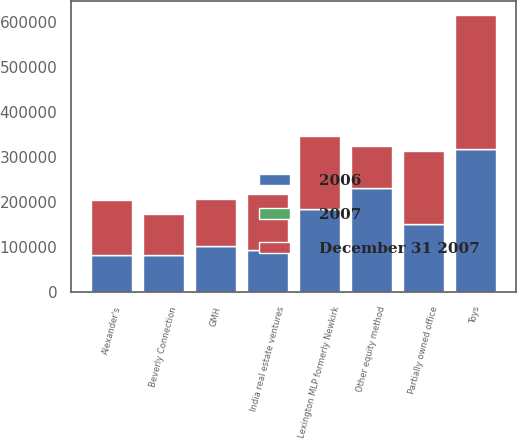Convert chart. <chart><loc_0><loc_0><loc_500><loc_500><stacked_bar_chart><ecel><fcel>Toys<fcel>Partially owned office<fcel>Lexington MLP formerly Newkirk<fcel>India real estate ventures<fcel>Alexander's<fcel>GMH<fcel>Beverly Connection<fcel>Other equity method<nl><fcel>2007<fcel>32.7<fcel>1<fcel>7.5<fcel>450<fcel>32.8<fcel>13.8<fcel>50<fcel>2<nl><fcel>December 31 2007<fcel>298089<fcel>161411<fcel>160868<fcel>123997<fcel>122797<fcel>103260<fcel>91302<fcel>93716<nl><fcel>2006<fcel>317145<fcel>150954<fcel>184961<fcel>93716<fcel>82114<fcel>103302<fcel>82101<fcel>231168<nl></chart> 